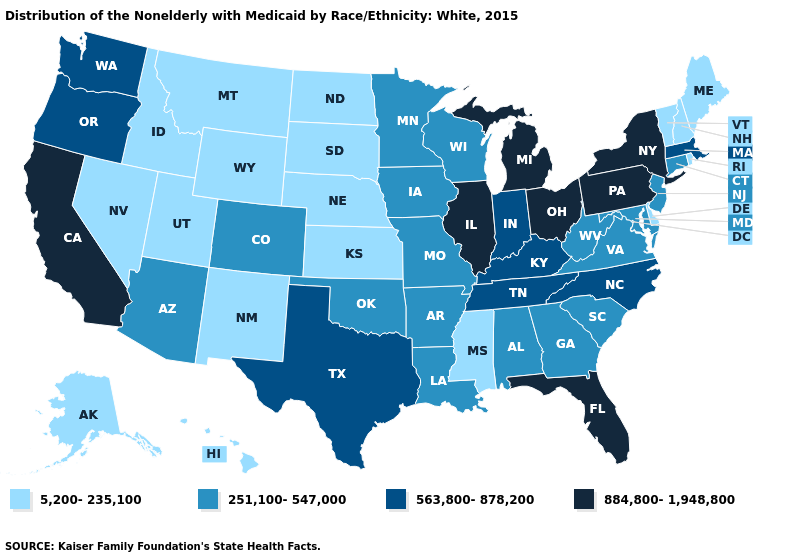What is the value of California?
Be succinct. 884,800-1,948,800. Among the states that border Kansas , which have the highest value?
Short answer required. Colorado, Missouri, Oklahoma. Among the states that border New Mexico , which have the lowest value?
Give a very brief answer. Utah. Among the states that border Alabama , which have the lowest value?
Be succinct. Mississippi. Among the states that border West Virginia , which have the highest value?
Quick response, please. Ohio, Pennsylvania. What is the lowest value in the Northeast?
Concise answer only. 5,200-235,100. What is the value of Indiana?
Keep it brief. 563,800-878,200. What is the highest value in states that border Minnesota?
Answer briefly. 251,100-547,000. Name the states that have a value in the range 251,100-547,000?
Concise answer only. Alabama, Arizona, Arkansas, Colorado, Connecticut, Georgia, Iowa, Louisiana, Maryland, Minnesota, Missouri, New Jersey, Oklahoma, South Carolina, Virginia, West Virginia, Wisconsin. Does the first symbol in the legend represent the smallest category?
Be succinct. Yes. What is the highest value in the West ?
Concise answer only. 884,800-1,948,800. Name the states that have a value in the range 884,800-1,948,800?
Give a very brief answer. California, Florida, Illinois, Michigan, New York, Ohio, Pennsylvania. Among the states that border Wyoming , which have the highest value?
Answer briefly. Colorado. Does Arizona have a lower value than New Jersey?
Quick response, please. No. What is the value of Vermont?
Short answer required. 5,200-235,100. 